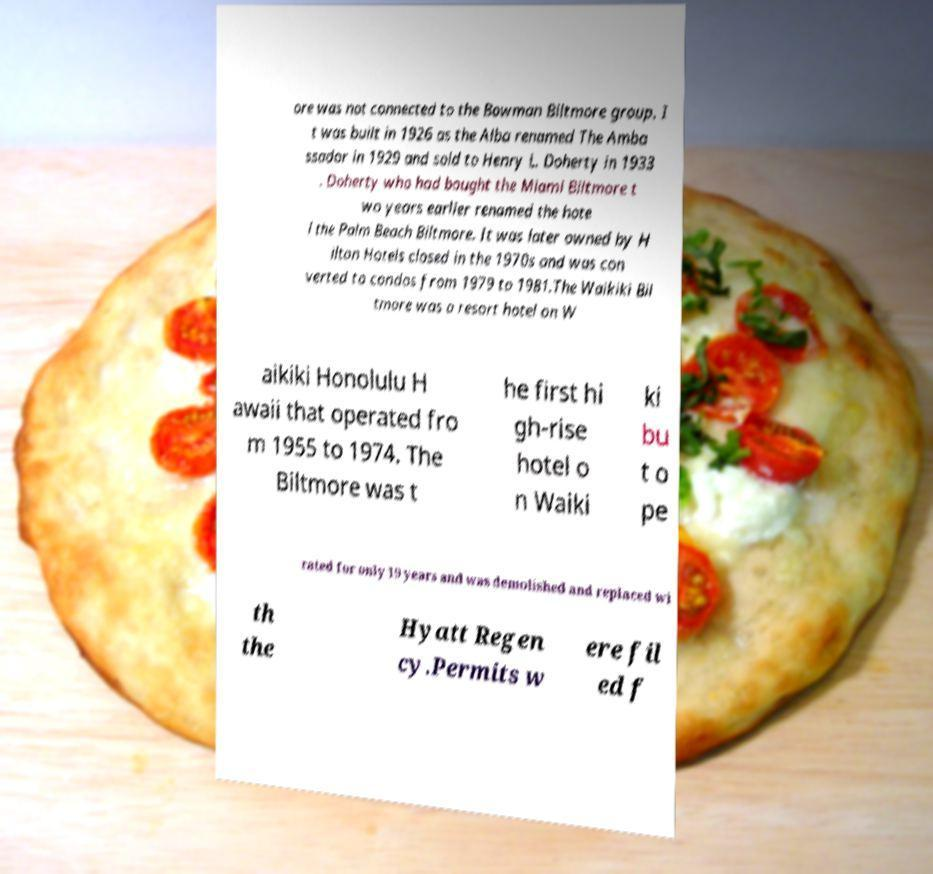Could you assist in decoding the text presented in this image and type it out clearly? ore was not connected to the Bowman Biltmore group. I t was built in 1926 as the Alba renamed The Amba ssador in 1929 and sold to Henry L. Doherty in 1933 . Doherty who had bought the Miami Biltmore t wo years earlier renamed the hote l the Palm Beach Biltmore. It was later owned by H ilton Hotels closed in the 1970s and was con verted to condos from 1979 to 1981.The Waikiki Bil tmore was a resort hotel on W aikiki Honolulu H awaii that operated fro m 1955 to 1974. The Biltmore was t he first hi gh-rise hotel o n Waiki ki bu t o pe rated for only 19 years and was demolished and replaced wi th the Hyatt Regen cy.Permits w ere fil ed f 